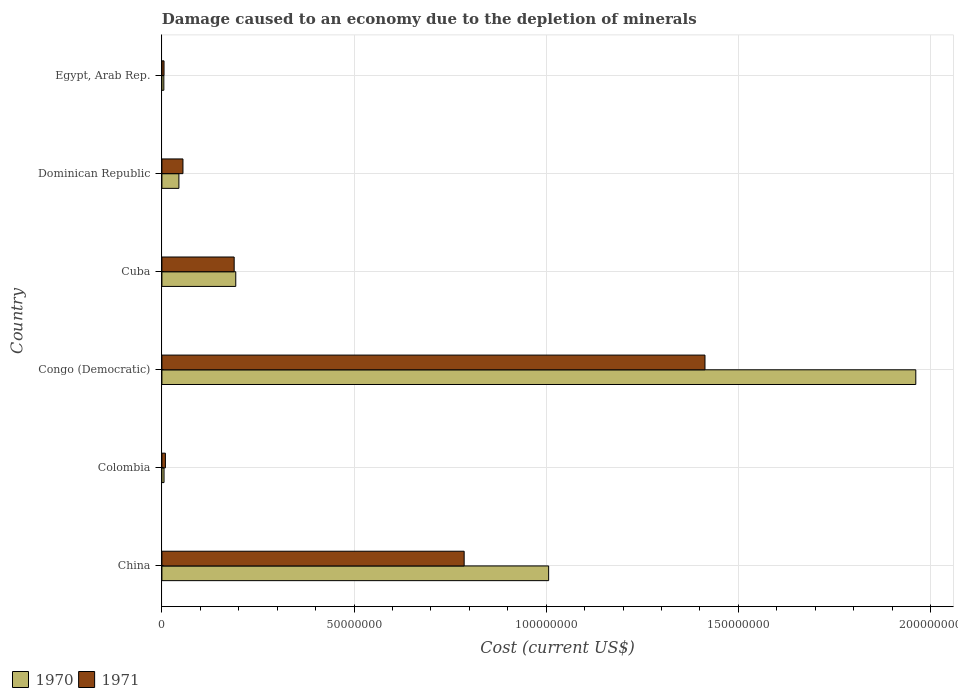How many groups of bars are there?
Your response must be concise. 6. How many bars are there on the 2nd tick from the bottom?
Keep it short and to the point. 2. What is the label of the 1st group of bars from the top?
Make the answer very short. Egypt, Arab Rep. What is the cost of damage caused due to the depletion of minerals in 1971 in Colombia?
Keep it short and to the point. 9.12e+05. Across all countries, what is the maximum cost of damage caused due to the depletion of minerals in 1970?
Give a very brief answer. 1.96e+08. Across all countries, what is the minimum cost of damage caused due to the depletion of minerals in 1970?
Make the answer very short. 5.07e+05. In which country was the cost of damage caused due to the depletion of minerals in 1970 maximum?
Your answer should be compact. Congo (Democratic). In which country was the cost of damage caused due to the depletion of minerals in 1970 minimum?
Your answer should be compact. Egypt, Arab Rep. What is the total cost of damage caused due to the depletion of minerals in 1970 in the graph?
Your response must be concise. 3.22e+08. What is the difference between the cost of damage caused due to the depletion of minerals in 1971 in China and that in Dominican Republic?
Your response must be concise. 7.32e+07. What is the difference between the cost of damage caused due to the depletion of minerals in 1971 in Congo (Democratic) and the cost of damage caused due to the depletion of minerals in 1970 in Dominican Republic?
Your response must be concise. 1.37e+08. What is the average cost of damage caused due to the depletion of minerals in 1971 per country?
Your answer should be very brief. 4.10e+07. What is the difference between the cost of damage caused due to the depletion of minerals in 1970 and cost of damage caused due to the depletion of minerals in 1971 in Cuba?
Offer a terse response. 4.14e+05. What is the ratio of the cost of damage caused due to the depletion of minerals in 1971 in Cuba to that in Dominican Republic?
Ensure brevity in your answer.  3.43. Is the difference between the cost of damage caused due to the depletion of minerals in 1970 in Colombia and Dominican Republic greater than the difference between the cost of damage caused due to the depletion of minerals in 1971 in Colombia and Dominican Republic?
Your answer should be very brief. Yes. What is the difference between the highest and the second highest cost of damage caused due to the depletion of minerals in 1970?
Provide a short and direct response. 9.55e+07. What is the difference between the highest and the lowest cost of damage caused due to the depletion of minerals in 1971?
Give a very brief answer. 1.41e+08. In how many countries, is the cost of damage caused due to the depletion of minerals in 1971 greater than the average cost of damage caused due to the depletion of minerals in 1971 taken over all countries?
Your answer should be very brief. 2. What does the 2nd bar from the top in China represents?
Keep it short and to the point. 1970. Are all the bars in the graph horizontal?
Give a very brief answer. Yes. How many countries are there in the graph?
Keep it short and to the point. 6. What is the difference between two consecutive major ticks on the X-axis?
Keep it short and to the point. 5.00e+07. Are the values on the major ticks of X-axis written in scientific E-notation?
Give a very brief answer. No. Does the graph contain grids?
Your answer should be compact. Yes. How are the legend labels stacked?
Provide a short and direct response. Horizontal. What is the title of the graph?
Your response must be concise. Damage caused to an economy due to the depletion of minerals. What is the label or title of the X-axis?
Your response must be concise. Cost (current US$). What is the label or title of the Y-axis?
Give a very brief answer. Country. What is the Cost (current US$) of 1970 in China?
Ensure brevity in your answer.  1.01e+08. What is the Cost (current US$) in 1971 in China?
Your answer should be very brief. 7.87e+07. What is the Cost (current US$) in 1970 in Colombia?
Give a very brief answer. 5.53e+05. What is the Cost (current US$) of 1971 in Colombia?
Ensure brevity in your answer.  9.12e+05. What is the Cost (current US$) of 1970 in Congo (Democratic)?
Provide a succinct answer. 1.96e+08. What is the Cost (current US$) in 1971 in Congo (Democratic)?
Give a very brief answer. 1.41e+08. What is the Cost (current US$) in 1970 in Cuba?
Provide a short and direct response. 1.92e+07. What is the Cost (current US$) of 1971 in Cuba?
Offer a very short reply. 1.88e+07. What is the Cost (current US$) of 1970 in Dominican Republic?
Provide a succinct answer. 4.43e+06. What is the Cost (current US$) of 1971 in Dominican Republic?
Keep it short and to the point. 5.48e+06. What is the Cost (current US$) of 1970 in Egypt, Arab Rep.?
Offer a terse response. 5.07e+05. What is the Cost (current US$) in 1971 in Egypt, Arab Rep.?
Make the answer very short. 5.55e+05. Across all countries, what is the maximum Cost (current US$) of 1970?
Your response must be concise. 1.96e+08. Across all countries, what is the maximum Cost (current US$) in 1971?
Ensure brevity in your answer.  1.41e+08. Across all countries, what is the minimum Cost (current US$) of 1970?
Your response must be concise. 5.07e+05. Across all countries, what is the minimum Cost (current US$) in 1971?
Ensure brevity in your answer.  5.55e+05. What is the total Cost (current US$) of 1970 in the graph?
Keep it short and to the point. 3.22e+08. What is the total Cost (current US$) in 1971 in the graph?
Ensure brevity in your answer.  2.46e+08. What is the difference between the Cost (current US$) of 1970 in China and that in Colombia?
Provide a succinct answer. 1.00e+08. What is the difference between the Cost (current US$) of 1971 in China and that in Colombia?
Your answer should be compact. 7.77e+07. What is the difference between the Cost (current US$) of 1970 in China and that in Congo (Democratic)?
Your answer should be compact. -9.55e+07. What is the difference between the Cost (current US$) in 1971 in China and that in Congo (Democratic)?
Offer a very short reply. -6.27e+07. What is the difference between the Cost (current US$) in 1970 in China and that in Cuba?
Your response must be concise. 8.14e+07. What is the difference between the Cost (current US$) of 1971 in China and that in Cuba?
Give a very brief answer. 5.98e+07. What is the difference between the Cost (current US$) of 1970 in China and that in Dominican Republic?
Ensure brevity in your answer.  9.62e+07. What is the difference between the Cost (current US$) in 1971 in China and that in Dominican Republic?
Ensure brevity in your answer.  7.32e+07. What is the difference between the Cost (current US$) of 1970 in China and that in Egypt, Arab Rep.?
Make the answer very short. 1.00e+08. What is the difference between the Cost (current US$) in 1971 in China and that in Egypt, Arab Rep.?
Ensure brevity in your answer.  7.81e+07. What is the difference between the Cost (current US$) in 1970 in Colombia and that in Congo (Democratic)?
Keep it short and to the point. -1.96e+08. What is the difference between the Cost (current US$) in 1971 in Colombia and that in Congo (Democratic)?
Offer a terse response. -1.40e+08. What is the difference between the Cost (current US$) in 1970 in Colombia and that in Cuba?
Give a very brief answer. -1.87e+07. What is the difference between the Cost (current US$) in 1971 in Colombia and that in Cuba?
Make the answer very short. -1.79e+07. What is the difference between the Cost (current US$) in 1970 in Colombia and that in Dominican Republic?
Provide a succinct answer. -3.87e+06. What is the difference between the Cost (current US$) of 1971 in Colombia and that in Dominican Republic?
Make the answer very short. -4.57e+06. What is the difference between the Cost (current US$) in 1970 in Colombia and that in Egypt, Arab Rep.?
Provide a short and direct response. 4.53e+04. What is the difference between the Cost (current US$) of 1971 in Colombia and that in Egypt, Arab Rep.?
Make the answer very short. 3.57e+05. What is the difference between the Cost (current US$) of 1970 in Congo (Democratic) and that in Cuba?
Provide a succinct answer. 1.77e+08. What is the difference between the Cost (current US$) in 1971 in Congo (Democratic) and that in Cuba?
Offer a very short reply. 1.23e+08. What is the difference between the Cost (current US$) in 1970 in Congo (Democratic) and that in Dominican Republic?
Offer a terse response. 1.92e+08. What is the difference between the Cost (current US$) of 1971 in Congo (Democratic) and that in Dominican Republic?
Your answer should be compact. 1.36e+08. What is the difference between the Cost (current US$) of 1970 in Congo (Democratic) and that in Egypt, Arab Rep.?
Make the answer very short. 1.96e+08. What is the difference between the Cost (current US$) in 1971 in Congo (Democratic) and that in Egypt, Arab Rep.?
Provide a succinct answer. 1.41e+08. What is the difference between the Cost (current US$) in 1970 in Cuba and that in Dominican Republic?
Provide a short and direct response. 1.48e+07. What is the difference between the Cost (current US$) of 1971 in Cuba and that in Dominican Republic?
Your answer should be very brief. 1.33e+07. What is the difference between the Cost (current US$) in 1970 in Cuba and that in Egypt, Arab Rep.?
Offer a very short reply. 1.87e+07. What is the difference between the Cost (current US$) of 1971 in Cuba and that in Egypt, Arab Rep.?
Offer a terse response. 1.83e+07. What is the difference between the Cost (current US$) of 1970 in Dominican Republic and that in Egypt, Arab Rep.?
Your response must be concise. 3.92e+06. What is the difference between the Cost (current US$) of 1971 in Dominican Republic and that in Egypt, Arab Rep.?
Give a very brief answer. 4.92e+06. What is the difference between the Cost (current US$) in 1970 in China and the Cost (current US$) in 1971 in Colombia?
Keep it short and to the point. 9.97e+07. What is the difference between the Cost (current US$) of 1970 in China and the Cost (current US$) of 1971 in Congo (Democratic)?
Make the answer very short. -4.07e+07. What is the difference between the Cost (current US$) of 1970 in China and the Cost (current US$) of 1971 in Cuba?
Give a very brief answer. 8.18e+07. What is the difference between the Cost (current US$) of 1970 in China and the Cost (current US$) of 1971 in Dominican Republic?
Provide a succinct answer. 9.52e+07. What is the difference between the Cost (current US$) of 1970 in China and the Cost (current US$) of 1971 in Egypt, Arab Rep.?
Provide a succinct answer. 1.00e+08. What is the difference between the Cost (current US$) in 1970 in Colombia and the Cost (current US$) in 1971 in Congo (Democratic)?
Your response must be concise. -1.41e+08. What is the difference between the Cost (current US$) of 1970 in Colombia and the Cost (current US$) of 1971 in Cuba?
Keep it short and to the point. -1.83e+07. What is the difference between the Cost (current US$) of 1970 in Colombia and the Cost (current US$) of 1971 in Dominican Republic?
Provide a succinct answer. -4.93e+06. What is the difference between the Cost (current US$) in 1970 in Colombia and the Cost (current US$) in 1971 in Egypt, Arab Rep.?
Keep it short and to the point. -2551.4. What is the difference between the Cost (current US$) in 1970 in Congo (Democratic) and the Cost (current US$) in 1971 in Cuba?
Your answer should be very brief. 1.77e+08. What is the difference between the Cost (current US$) in 1970 in Congo (Democratic) and the Cost (current US$) in 1971 in Dominican Republic?
Provide a short and direct response. 1.91e+08. What is the difference between the Cost (current US$) in 1970 in Congo (Democratic) and the Cost (current US$) in 1971 in Egypt, Arab Rep.?
Your answer should be compact. 1.96e+08. What is the difference between the Cost (current US$) of 1970 in Cuba and the Cost (current US$) of 1971 in Dominican Republic?
Ensure brevity in your answer.  1.37e+07. What is the difference between the Cost (current US$) of 1970 in Cuba and the Cost (current US$) of 1971 in Egypt, Arab Rep.?
Your answer should be very brief. 1.87e+07. What is the difference between the Cost (current US$) in 1970 in Dominican Republic and the Cost (current US$) in 1971 in Egypt, Arab Rep.?
Keep it short and to the point. 3.87e+06. What is the average Cost (current US$) of 1970 per country?
Provide a succinct answer. 5.36e+07. What is the average Cost (current US$) of 1971 per country?
Provide a succinct answer. 4.10e+07. What is the difference between the Cost (current US$) of 1970 and Cost (current US$) of 1971 in China?
Offer a very short reply. 2.20e+07. What is the difference between the Cost (current US$) of 1970 and Cost (current US$) of 1971 in Colombia?
Give a very brief answer. -3.59e+05. What is the difference between the Cost (current US$) in 1970 and Cost (current US$) in 1971 in Congo (Democratic)?
Offer a very short reply. 5.49e+07. What is the difference between the Cost (current US$) of 1970 and Cost (current US$) of 1971 in Cuba?
Your answer should be compact. 4.14e+05. What is the difference between the Cost (current US$) of 1970 and Cost (current US$) of 1971 in Dominican Republic?
Provide a short and direct response. -1.05e+06. What is the difference between the Cost (current US$) in 1970 and Cost (current US$) in 1971 in Egypt, Arab Rep.?
Provide a short and direct response. -4.79e+04. What is the ratio of the Cost (current US$) in 1970 in China to that in Colombia?
Provide a short and direct response. 182.11. What is the ratio of the Cost (current US$) of 1971 in China to that in Colombia?
Your answer should be very brief. 86.24. What is the ratio of the Cost (current US$) in 1970 in China to that in Congo (Democratic)?
Ensure brevity in your answer.  0.51. What is the ratio of the Cost (current US$) in 1971 in China to that in Congo (Democratic)?
Offer a terse response. 0.56. What is the ratio of the Cost (current US$) in 1970 in China to that in Cuba?
Provide a succinct answer. 5.24. What is the ratio of the Cost (current US$) in 1971 in China to that in Cuba?
Provide a short and direct response. 4.18. What is the ratio of the Cost (current US$) in 1970 in China to that in Dominican Republic?
Your answer should be compact. 22.73. What is the ratio of the Cost (current US$) of 1971 in China to that in Dominican Republic?
Make the answer very short. 14.36. What is the ratio of the Cost (current US$) of 1970 in China to that in Egypt, Arab Rep.?
Ensure brevity in your answer.  198.37. What is the ratio of the Cost (current US$) of 1971 in China to that in Egypt, Arab Rep.?
Offer a terse response. 141.68. What is the ratio of the Cost (current US$) of 1970 in Colombia to that in Congo (Democratic)?
Offer a terse response. 0. What is the ratio of the Cost (current US$) of 1971 in Colombia to that in Congo (Democratic)?
Ensure brevity in your answer.  0.01. What is the ratio of the Cost (current US$) of 1970 in Colombia to that in Cuba?
Provide a short and direct response. 0.03. What is the ratio of the Cost (current US$) of 1971 in Colombia to that in Cuba?
Keep it short and to the point. 0.05. What is the ratio of the Cost (current US$) in 1970 in Colombia to that in Dominican Republic?
Your response must be concise. 0.12. What is the ratio of the Cost (current US$) of 1971 in Colombia to that in Dominican Republic?
Give a very brief answer. 0.17. What is the ratio of the Cost (current US$) of 1970 in Colombia to that in Egypt, Arab Rep.?
Your response must be concise. 1.09. What is the ratio of the Cost (current US$) in 1971 in Colombia to that in Egypt, Arab Rep.?
Offer a terse response. 1.64. What is the ratio of the Cost (current US$) in 1970 in Congo (Democratic) to that in Cuba?
Your answer should be compact. 10.21. What is the ratio of the Cost (current US$) in 1971 in Congo (Democratic) to that in Cuba?
Provide a short and direct response. 7.51. What is the ratio of the Cost (current US$) in 1970 in Congo (Democratic) to that in Dominican Republic?
Your answer should be compact. 44.31. What is the ratio of the Cost (current US$) of 1971 in Congo (Democratic) to that in Dominican Republic?
Ensure brevity in your answer.  25.8. What is the ratio of the Cost (current US$) in 1970 in Congo (Democratic) to that in Egypt, Arab Rep.?
Ensure brevity in your answer.  386.71. What is the ratio of the Cost (current US$) of 1971 in Congo (Democratic) to that in Egypt, Arab Rep.?
Give a very brief answer. 254.55. What is the ratio of the Cost (current US$) of 1970 in Cuba to that in Dominican Republic?
Give a very brief answer. 4.34. What is the ratio of the Cost (current US$) of 1971 in Cuba to that in Dominican Republic?
Provide a succinct answer. 3.43. What is the ratio of the Cost (current US$) in 1970 in Cuba to that in Egypt, Arab Rep.?
Provide a short and direct response. 37.89. What is the ratio of the Cost (current US$) in 1971 in Cuba to that in Egypt, Arab Rep.?
Offer a very short reply. 33.88. What is the ratio of the Cost (current US$) in 1970 in Dominican Republic to that in Egypt, Arab Rep.?
Make the answer very short. 8.73. What is the ratio of the Cost (current US$) of 1971 in Dominican Republic to that in Egypt, Arab Rep.?
Offer a very short reply. 9.87. What is the difference between the highest and the second highest Cost (current US$) of 1970?
Ensure brevity in your answer.  9.55e+07. What is the difference between the highest and the second highest Cost (current US$) of 1971?
Provide a succinct answer. 6.27e+07. What is the difference between the highest and the lowest Cost (current US$) in 1970?
Offer a terse response. 1.96e+08. What is the difference between the highest and the lowest Cost (current US$) in 1971?
Make the answer very short. 1.41e+08. 